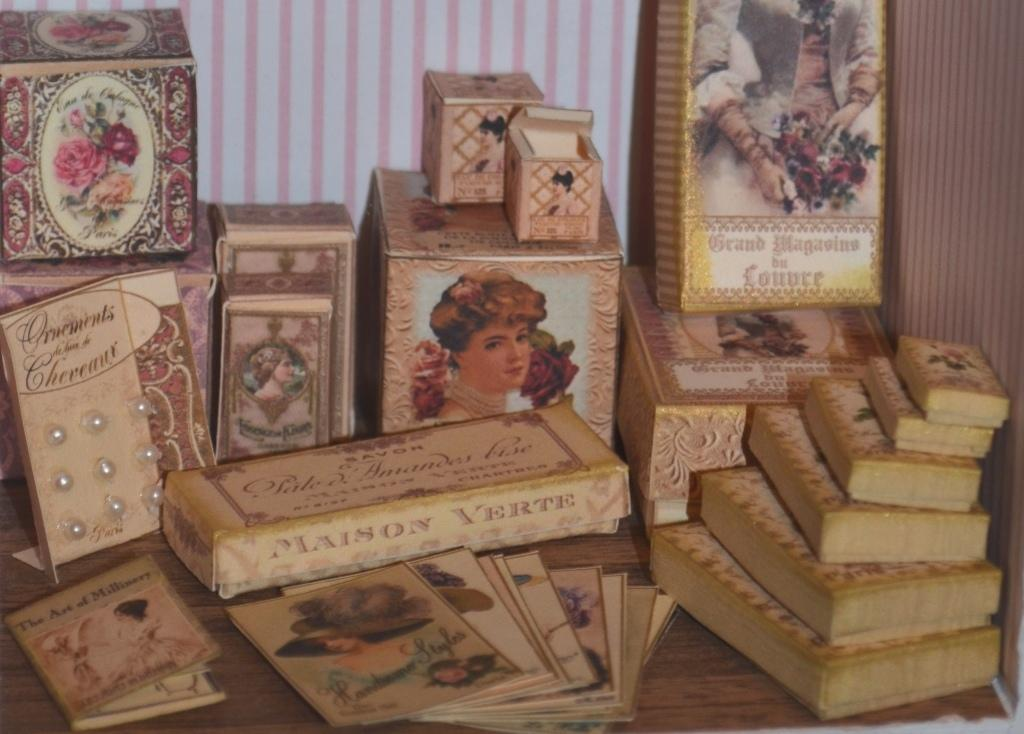<image>
Share a concise interpretation of the image provided. Various books sit on a table like Grand Magasins bu Lonure 